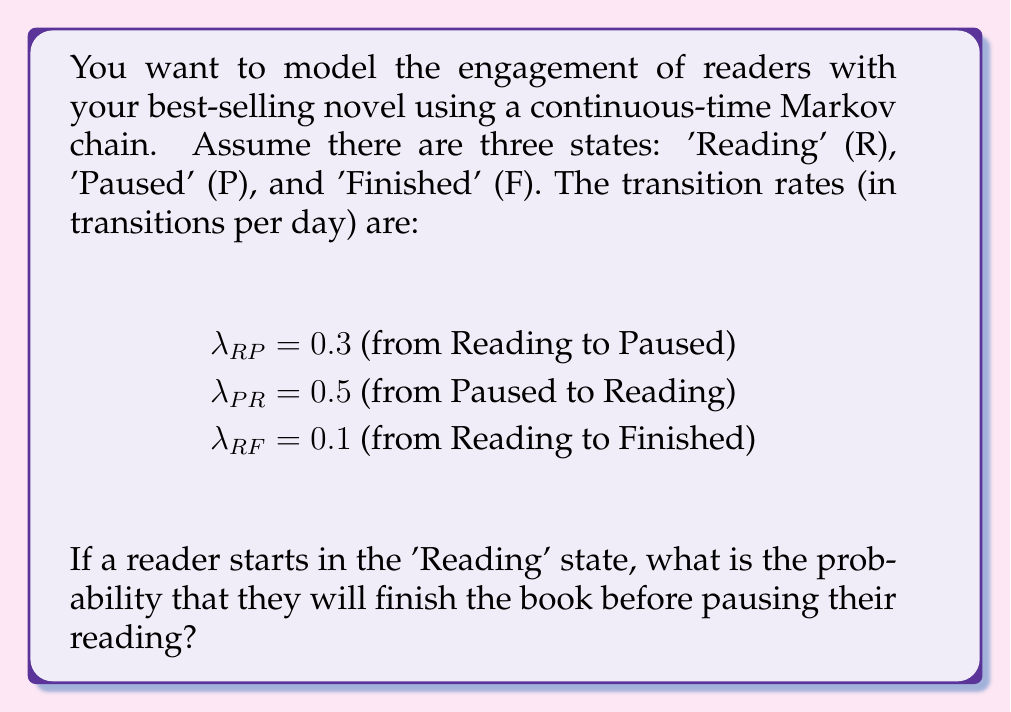Teach me how to tackle this problem. To solve this problem, we need to use the concept of competing exponential processes in continuous-time Markov chains.

1) From the 'Reading' state, there are two possible transitions: to 'Paused' or to 'Finished'.

2) The time until each of these transitions occurs follows an exponential distribution:
   - Time to Pause ~ Exp($\lambda_{RP} = 0.3$)
   - Time to Finish ~ Exp($\lambda_{RF} = 0.1$)

3) In a race between two exponential distributions, the probability of one occurring before the other is proportional to its rate.

4) The probability of finishing before pausing is:

   $$P(\text{Finish before Pause}) = \frac{\lambda_{RF}}{\lambda_{RP} + \lambda_{RF}}$$

5) Substituting the given values:

   $$P(\text{Finish before Pause}) = \frac{0.1}{0.3 + 0.1} = \frac{0.1}{0.4} = \frac{1}{4} = 0.25$$

Therefore, the probability that a reader will finish the book before pausing their reading is 0.25 or 25%.
Answer: 0.25 